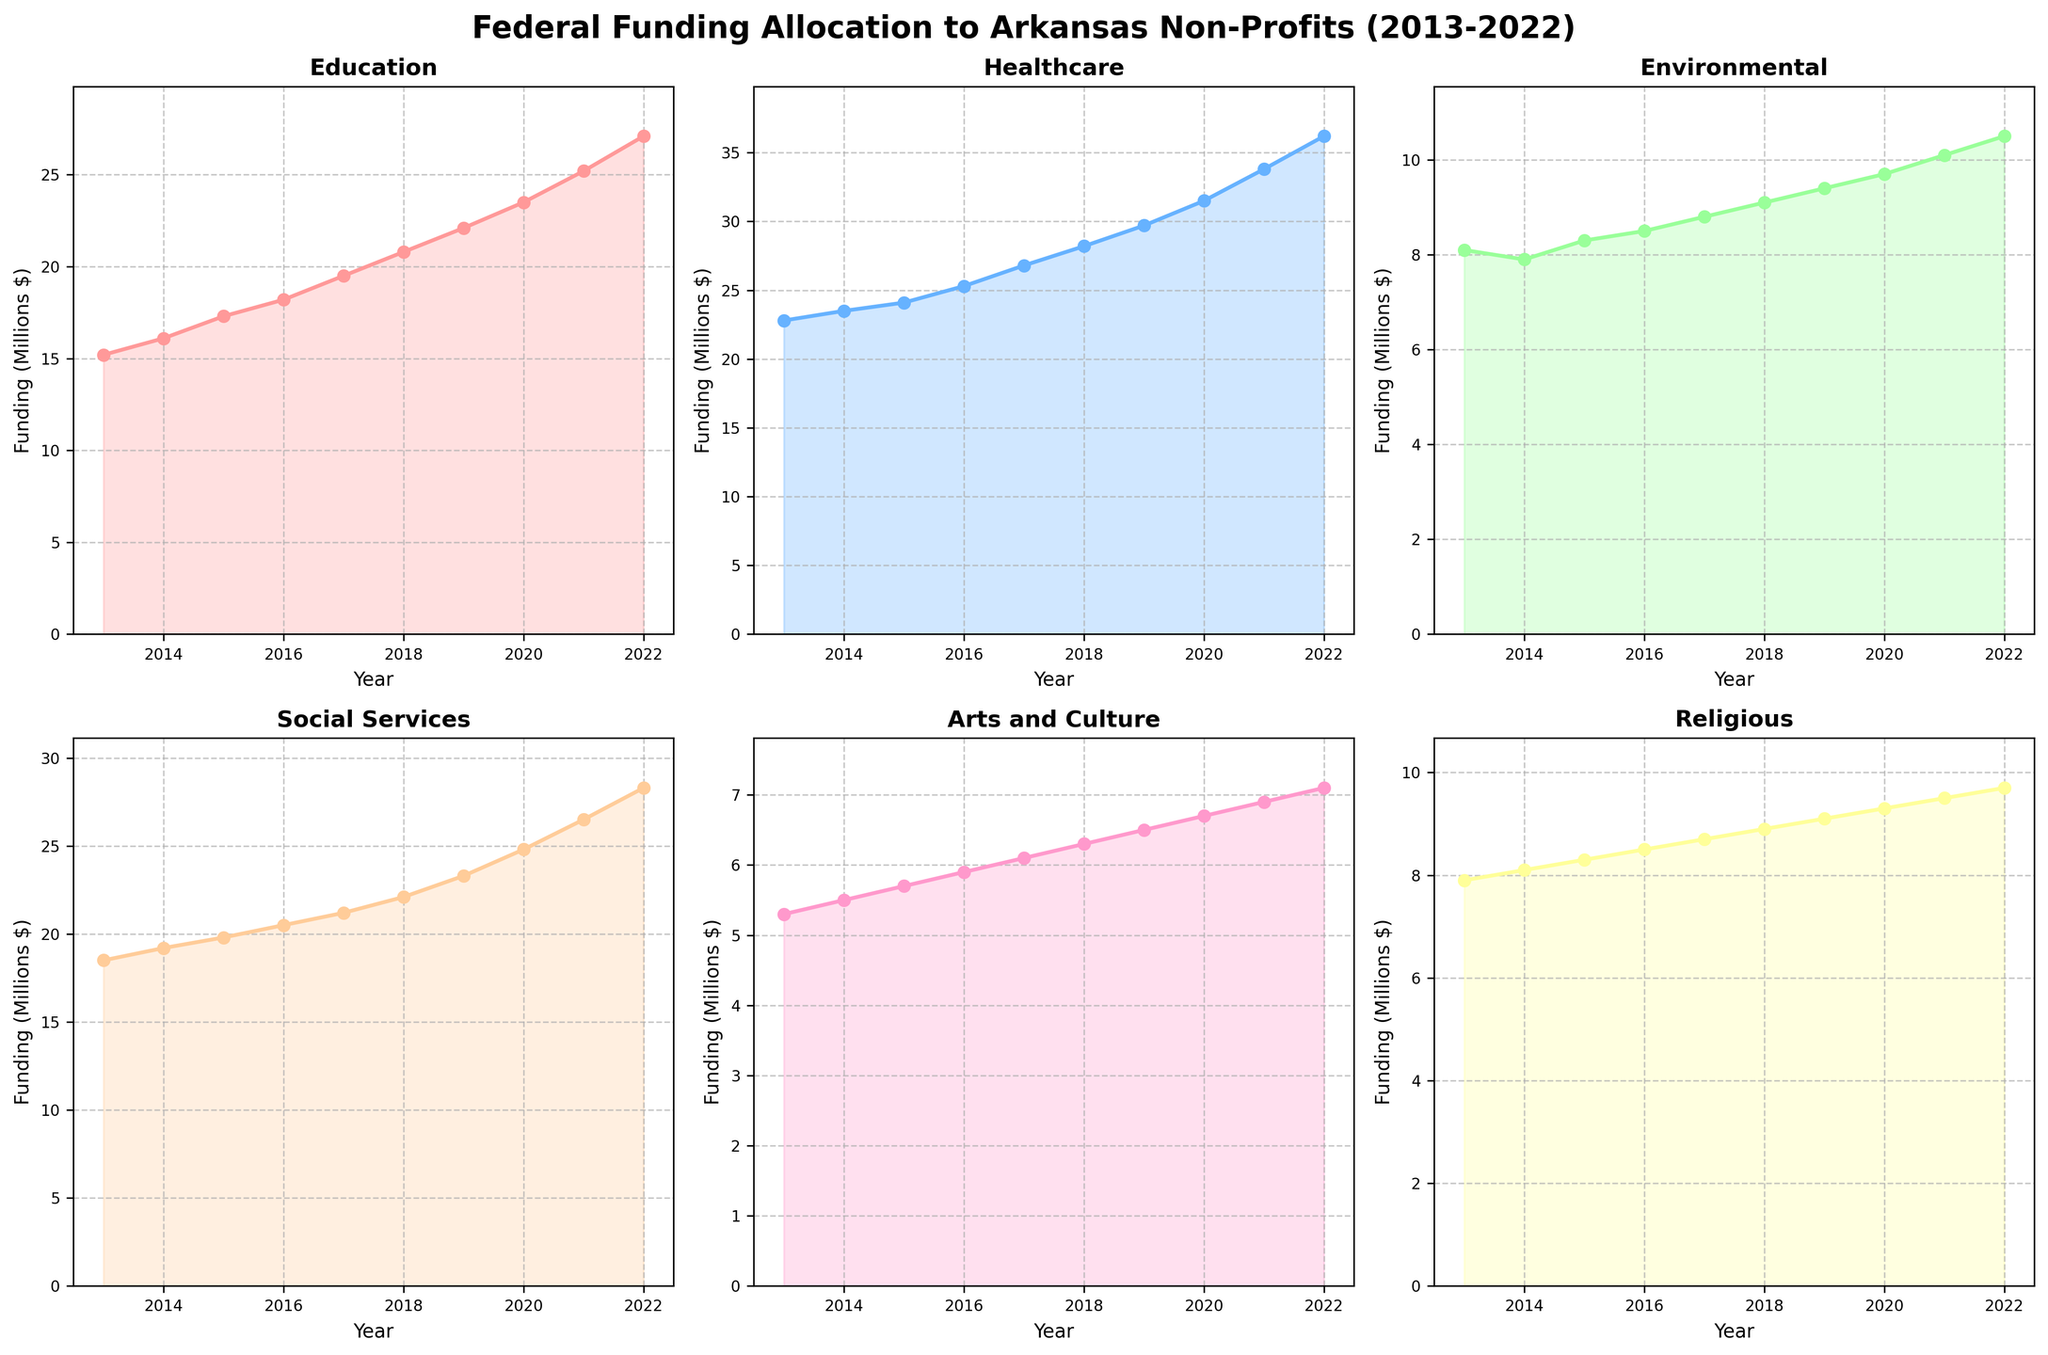What's the highest federal funding for Healthcare in any given year from 2013 to 2022? To answer this, look at the Healthcare subplot within the figure. The highest point in this plot reaches 36.2 million dollars in 2022.
Answer: 36.2 million dollars What's the average federal funding for Social Services from 2013 to 2022? First, sum up the funding values for Social Services: 18.5, 19.2, 19.8, 20.5, 21.2, 22.1, 23.3, 24.8, 26.5, and 28.3. The total is 224.2. Then, divide by the number of years (10). The average is 224.2 / 10 = 22.42 million dollars.
Answer: 22.42 million dollars Which sector had the smallest increase in federal funding from 2013 to 2022? For each sector, subtract the 2013 funding value from the 2022 value: Education (27.1-15.2), Healthcare (36.2-22.8), Environmental (10.5-8.1), Social Services (28.3-18.5), Arts and Culture (7.1-5.3), Religious (9.7-7.9). The smallest increase is for the Arts and Culture sector (7.1-5.3 = 1.8 million dollars).
Answer: Arts and Culture In which year did Education funding first exceed 20 million dollars? Look at the Education subplot and find the first year the funding exceeds 20 million dollars. This happens in 2018 when it reaches 20.8 million dollars.
Answer: 2018 Compare the federal funding trends for Healthcare and Environmental sectors. Which one had a steeper increase? Calculate the difference in funding from 2013 to 2022 for both sectors: Healthcare (36.2-22.8 = 13.4) and Environmental (10.5-8.1 = 2.4). Healthcare had a steeper increase.
Answer: Healthcare During which year was the funding for Religious non-profits closest to 9 million dollars? Look at the Religious subplot and find the year when the funding is closest to 9 million dollars. This occurs in 2019 when the funding is exactly 9.1 million dollars.
Answer: 2019 What is the total federal funding for Environmental sector over the decade from 2013 to 2022? Sum the values for Environmental sector: 8.1, 7.9, 8.3, 8.5, 8.8, 9.1, 9.4, 9.7, 10.1, and 10.5. The total funding is 90.4 million dollars.
Answer: 90.4 million dollars In 2020, what is the difference in federal funding between Social Services and Arts and Culture? Look at the subplot for 2020, subtract the Arts and Culture funding (6.7) from Social Services funding (24.8). The difference is 24.8 - 6.7 = 18.1 million dollars.
Answer: 18.1 million dollars Which sector showed the most consistent year-over-year increase in federal funding over the decade? Examine the year-over-year increase for each sector. The Education sector shows a steady, consistent increase each year from 15.2 million in 2013 to 27.1 million in 2022.
Answer: Education 